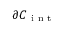<formula> <loc_0><loc_0><loc_500><loc_500>\partial { C } _ { i n t }</formula> 